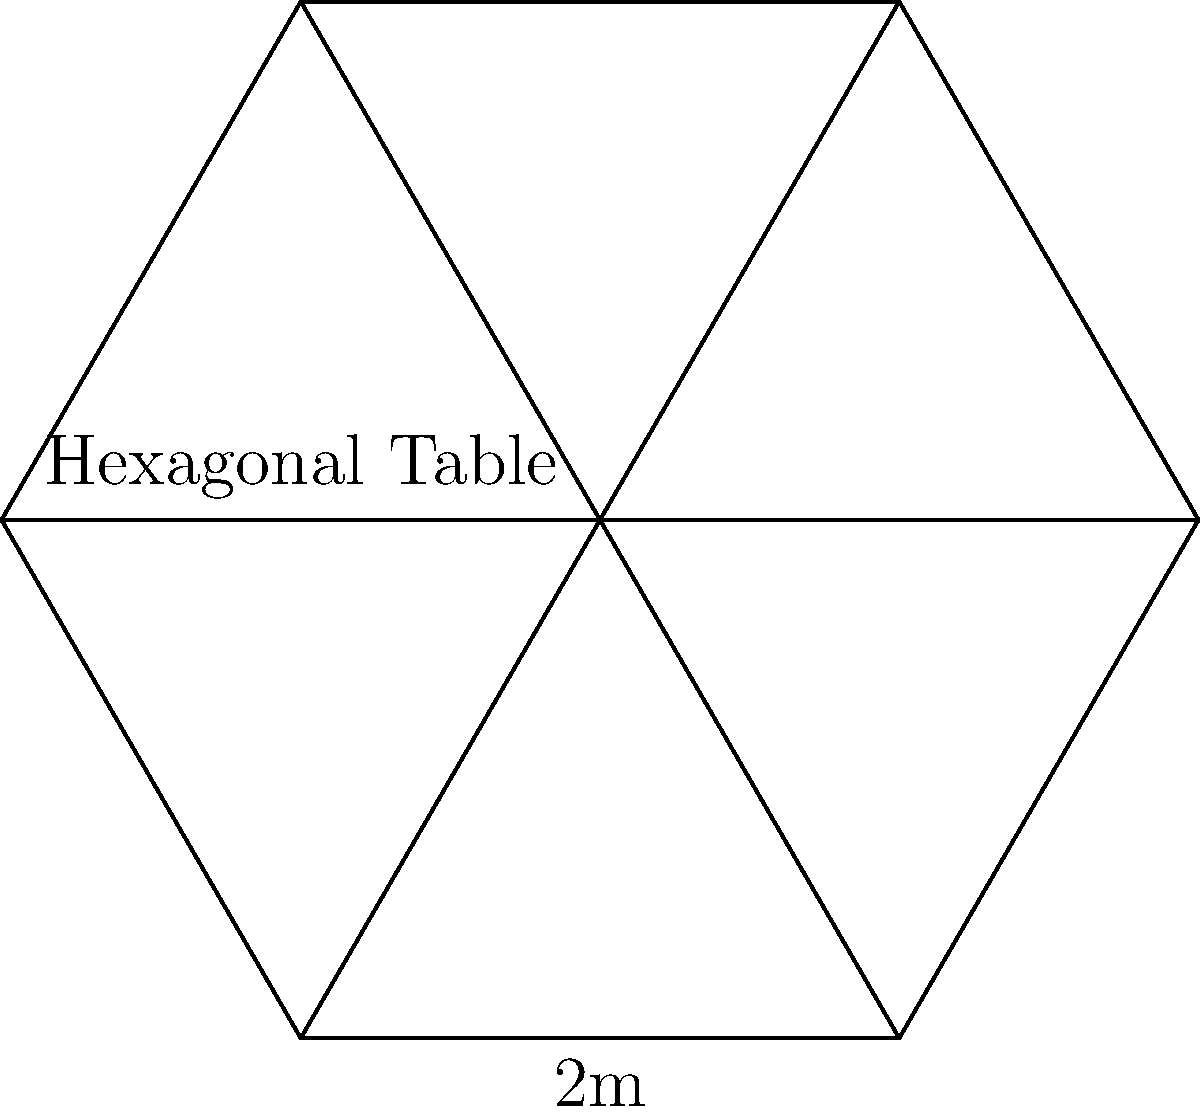You're designing a unique hexagonal dining table for an Australian-Iraqi fusion restaurant. The table has a side length of 2 meters. Calculate the perimeter of this hexagonal table. To calculate the perimeter of a regular hexagon, we need to follow these steps:

1) In a regular hexagon, all sides are equal in length.
2) The given side length is 2 meters.
3) A hexagon has 6 sides.
4) The formula for the perimeter of a regular hexagon is:

   $$P = 6s$$

   where $P$ is the perimeter and $s$ is the side length.

5) Substituting the given side length:

   $$P = 6 \times 2$$

6) Calculating:

   $$P = 12$$

Therefore, the perimeter of the hexagonal dining table is 12 meters.
Answer: 12 meters 